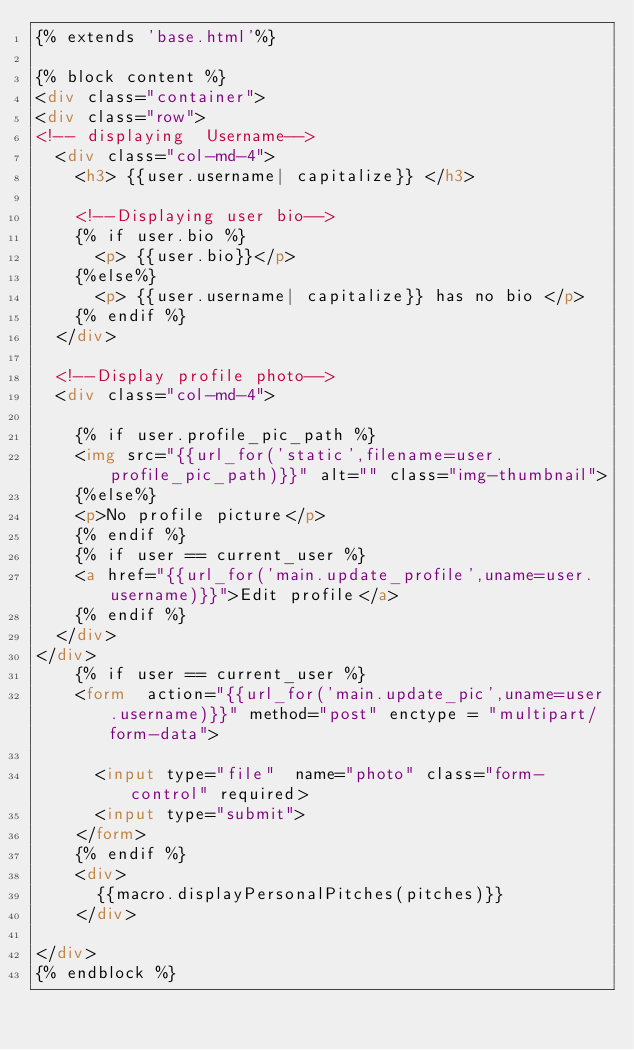Convert code to text. <code><loc_0><loc_0><loc_500><loc_500><_HTML_>{% extends 'base.html'%}

{% block content %}
<div class="container">
<div class="row">
<!-- displaying  Username-->
  <div class="col-md-4">
    <h3> {{user.username| capitalize}} </h3>

    <!--Displaying user bio-->
    {% if user.bio %}
      <p> {{user.bio}}</p>
    {%else%}
      <p> {{user.username| capitalize}} has no bio </p>
    {% endif %}
  </div>

  <!--Display profile photo-->
  <div class="col-md-4">

    {% if user.profile_pic_path %}
    <img src="{{url_for('static',filename=user.profile_pic_path)}}" alt="" class="img-thumbnail">
    {%else%}
    <p>No profile picture</p>
    {% endif %}
    {% if user == current_user %}
    <a href="{{url_for('main.update_profile',uname=user.username)}}">Edit profile</a>
    {% endif %}
  </div>
</div>
    {% if user == current_user %}
    <form  action="{{url_for('main.update_pic',uname=user.username)}}" method="post" enctype = "multipart/form-data">

      <input type="file"  name="photo" class="form-control" required>
      <input type="submit">
    </form>
    {% endif %}
    <div>
      {{macro.displayPersonalPitches(pitches)}}
    </div>
    
</div>
{% endblock %}</code> 